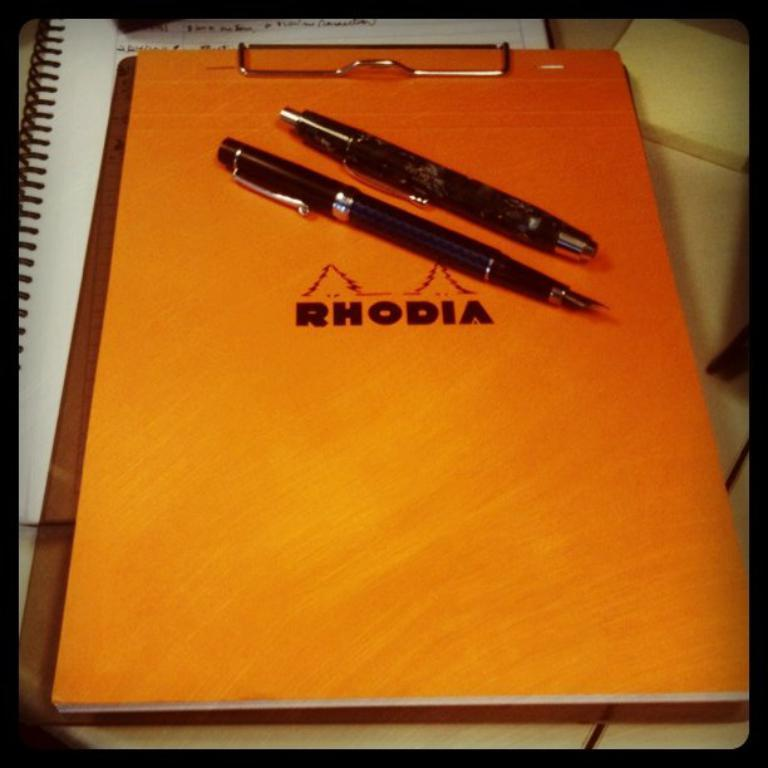What is the main object in the image? There is a book in the image. What writing instruments are visible in the image? There are pens in the image. Where are the pens placed? The pens are on an exam pad. What is located under the exam pad? There is a notepad under the exam pad. How many wings can be seen on the book in the image? There are no wings present on the book in the image. What type of lumber is used to make the pens in the image? There is no information about the pens' materials in the image, and there are no lumber-related objects present. 